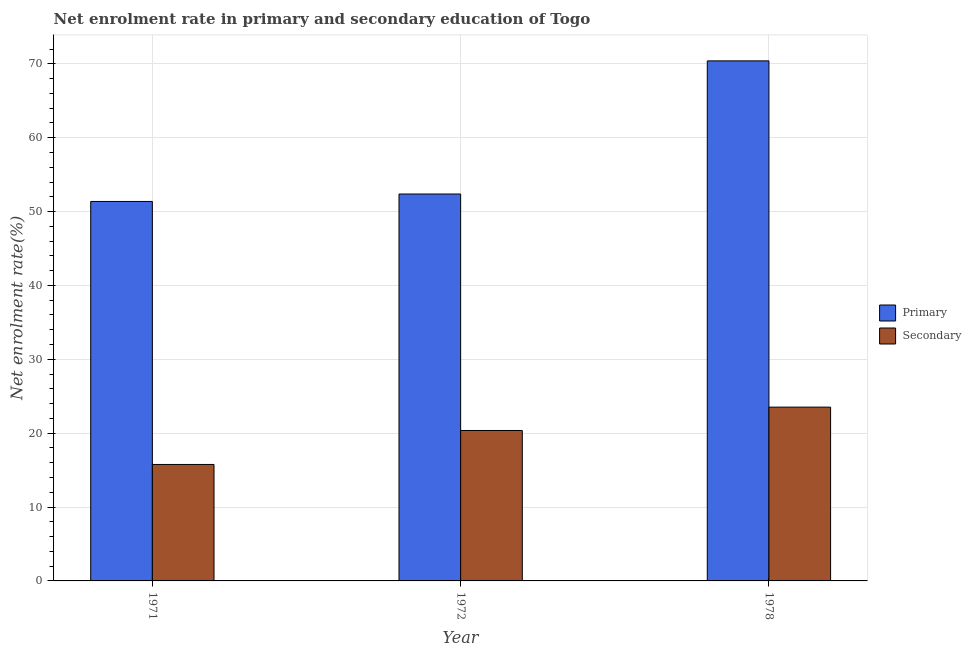Are the number of bars per tick equal to the number of legend labels?
Offer a very short reply. Yes. Are the number of bars on each tick of the X-axis equal?
Offer a very short reply. Yes. How many bars are there on the 1st tick from the left?
Provide a succinct answer. 2. What is the label of the 1st group of bars from the left?
Provide a short and direct response. 1971. In how many cases, is the number of bars for a given year not equal to the number of legend labels?
Give a very brief answer. 0. What is the enrollment rate in secondary education in 1972?
Give a very brief answer. 20.36. Across all years, what is the maximum enrollment rate in primary education?
Your answer should be very brief. 70.4. Across all years, what is the minimum enrollment rate in primary education?
Your answer should be compact. 51.37. In which year was the enrollment rate in secondary education maximum?
Your response must be concise. 1978. What is the total enrollment rate in secondary education in the graph?
Give a very brief answer. 59.66. What is the difference between the enrollment rate in primary education in 1972 and that in 1978?
Keep it short and to the point. -18.02. What is the difference between the enrollment rate in primary education in 1971 and the enrollment rate in secondary education in 1978?
Offer a terse response. -19.03. What is the average enrollment rate in primary education per year?
Your answer should be very brief. 58.05. In the year 1978, what is the difference between the enrollment rate in secondary education and enrollment rate in primary education?
Your answer should be very brief. 0. What is the ratio of the enrollment rate in primary education in 1971 to that in 1978?
Ensure brevity in your answer.  0.73. What is the difference between the highest and the second highest enrollment rate in primary education?
Offer a terse response. 18.02. What is the difference between the highest and the lowest enrollment rate in primary education?
Give a very brief answer. 19.03. In how many years, is the enrollment rate in primary education greater than the average enrollment rate in primary education taken over all years?
Make the answer very short. 1. Is the sum of the enrollment rate in secondary education in 1971 and 1972 greater than the maximum enrollment rate in primary education across all years?
Keep it short and to the point. Yes. What does the 1st bar from the left in 1971 represents?
Make the answer very short. Primary. What does the 2nd bar from the right in 1972 represents?
Give a very brief answer. Primary. How many bars are there?
Offer a very short reply. 6. Are all the bars in the graph horizontal?
Your response must be concise. No. How many years are there in the graph?
Make the answer very short. 3. What is the difference between two consecutive major ticks on the Y-axis?
Make the answer very short. 10. Does the graph contain any zero values?
Your answer should be compact. No. Does the graph contain grids?
Your answer should be compact. Yes. How many legend labels are there?
Your answer should be very brief. 2. How are the legend labels stacked?
Ensure brevity in your answer.  Vertical. What is the title of the graph?
Offer a terse response. Net enrolment rate in primary and secondary education of Togo. Does "RDB nonconcessional" appear as one of the legend labels in the graph?
Give a very brief answer. No. What is the label or title of the X-axis?
Your answer should be compact. Year. What is the label or title of the Y-axis?
Your answer should be very brief. Net enrolment rate(%). What is the Net enrolment rate(%) of Primary in 1971?
Make the answer very short. 51.37. What is the Net enrolment rate(%) in Secondary in 1971?
Provide a short and direct response. 15.77. What is the Net enrolment rate(%) of Primary in 1972?
Ensure brevity in your answer.  52.38. What is the Net enrolment rate(%) of Secondary in 1972?
Your answer should be very brief. 20.36. What is the Net enrolment rate(%) of Primary in 1978?
Your answer should be very brief. 70.4. What is the Net enrolment rate(%) in Secondary in 1978?
Offer a very short reply. 23.53. Across all years, what is the maximum Net enrolment rate(%) of Primary?
Your response must be concise. 70.4. Across all years, what is the maximum Net enrolment rate(%) in Secondary?
Your answer should be very brief. 23.53. Across all years, what is the minimum Net enrolment rate(%) in Primary?
Your response must be concise. 51.37. Across all years, what is the minimum Net enrolment rate(%) in Secondary?
Your answer should be very brief. 15.77. What is the total Net enrolment rate(%) of Primary in the graph?
Offer a very short reply. 174.15. What is the total Net enrolment rate(%) of Secondary in the graph?
Offer a very short reply. 59.66. What is the difference between the Net enrolment rate(%) of Primary in 1971 and that in 1972?
Your response must be concise. -1.01. What is the difference between the Net enrolment rate(%) of Secondary in 1971 and that in 1972?
Keep it short and to the point. -4.6. What is the difference between the Net enrolment rate(%) in Primary in 1971 and that in 1978?
Your response must be concise. -19.03. What is the difference between the Net enrolment rate(%) in Secondary in 1971 and that in 1978?
Offer a terse response. -7.76. What is the difference between the Net enrolment rate(%) in Primary in 1972 and that in 1978?
Provide a succinct answer. -18.02. What is the difference between the Net enrolment rate(%) of Secondary in 1972 and that in 1978?
Provide a short and direct response. -3.16. What is the difference between the Net enrolment rate(%) in Primary in 1971 and the Net enrolment rate(%) in Secondary in 1972?
Your answer should be very brief. 31.01. What is the difference between the Net enrolment rate(%) of Primary in 1971 and the Net enrolment rate(%) of Secondary in 1978?
Your answer should be compact. 27.84. What is the difference between the Net enrolment rate(%) of Primary in 1972 and the Net enrolment rate(%) of Secondary in 1978?
Keep it short and to the point. 28.85. What is the average Net enrolment rate(%) in Primary per year?
Keep it short and to the point. 58.05. What is the average Net enrolment rate(%) in Secondary per year?
Offer a terse response. 19.89. In the year 1971, what is the difference between the Net enrolment rate(%) of Primary and Net enrolment rate(%) of Secondary?
Offer a terse response. 35.61. In the year 1972, what is the difference between the Net enrolment rate(%) in Primary and Net enrolment rate(%) in Secondary?
Your response must be concise. 32.01. In the year 1978, what is the difference between the Net enrolment rate(%) in Primary and Net enrolment rate(%) in Secondary?
Offer a very short reply. 46.87. What is the ratio of the Net enrolment rate(%) of Primary in 1971 to that in 1972?
Your response must be concise. 0.98. What is the ratio of the Net enrolment rate(%) of Secondary in 1971 to that in 1972?
Give a very brief answer. 0.77. What is the ratio of the Net enrolment rate(%) of Primary in 1971 to that in 1978?
Offer a very short reply. 0.73. What is the ratio of the Net enrolment rate(%) of Secondary in 1971 to that in 1978?
Offer a terse response. 0.67. What is the ratio of the Net enrolment rate(%) of Primary in 1972 to that in 1978?
Your answer should be very brief. 0.74. What is the ratio of the Net enrolment rate(%) of Secondary in 1972 to that in 1978?
Keep it short and to the point. 0.87. What is the difference between the highest and the second highest Net enrolment rate(%) in Primary?
Provide a succinct answer. 18.02. What is the difference between the highest and the second highest Net enrolment rate(%) in Secondary?
Ensure brevity in your answer.  3.16. What is the difference between the highest and the lowest Net enrolment rate(%) of Primary?
Offer a terse response. 19.03. What is the difference between the highest and the lowest Net enrolment rate(%) in Secondary?
Your response must be concise. 7.76. 